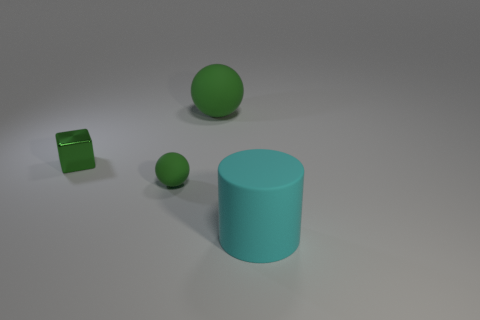Subtract all cubes. How many objects are left? 3 Add 2 large purple rubber cylinders. How many objects exist? 6 Subtract all purple metallic blocks. Subtract all large green matte objects. How many objects are left? 3 Add 1 green metallic blocks. How many green metallic blocks are left? 2 Add 1 small green metal things. How many small green metal things exist? 2 Subtract 0 red cylinders. How many objects are left? 4 Subtract 1 cubes. How many cubes are left? 0 Subtract all brown cubes. Subtract all cyan cylinders. How many cubes are left? 1 Subtract all red cylinders. How many cyan balls are left? 0 